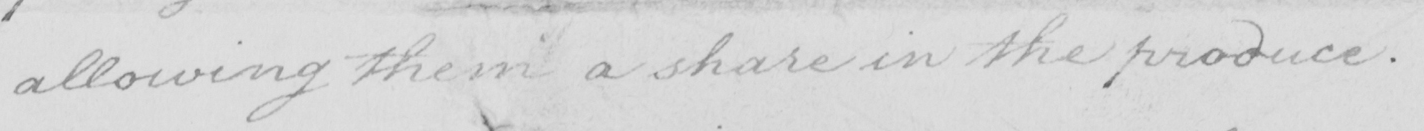What is written in this line of handwriting? allowing them a share in the produce . 